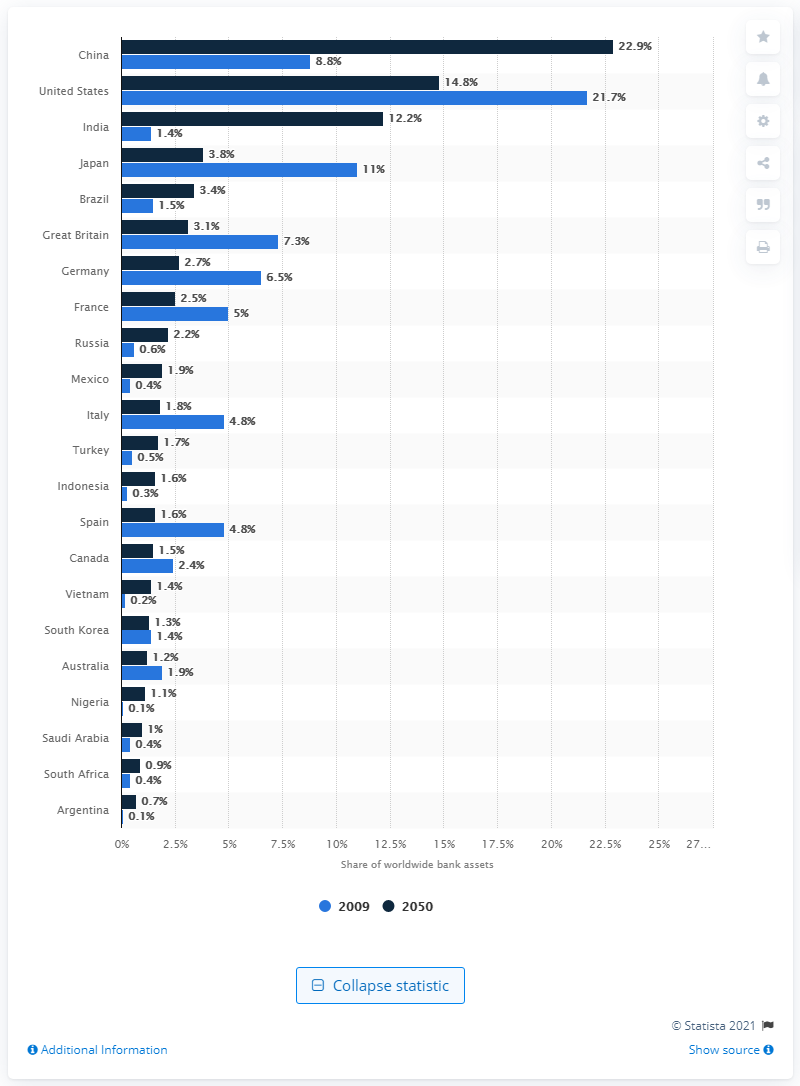Identify some key points in this picture. In 2009, South Africa's share of worldwide bank assets was 0.4%. The prediction for South Africa's share of bank assets in 2050 is expected to be 0.9%. The forecast for the share of bank assets worldwide in selected countries by 2050 is expected to be significant. 